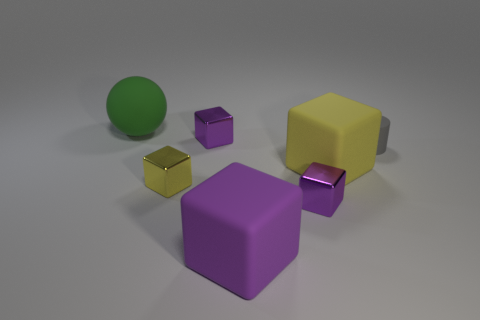Does the yellow object that is in front of the big yellow object have the same material as the tiny gray thing?
Provide a short and direct response. No. Are there any small purple blocks that are behind the green object that is behind the small rubber cylinder that is to the right of the yellow metallic object?
Your answer should be very brief. No. What number of balls are either small matte objects or tiny yellow metallic things?
Offer a terse response. 0. What is the material of the object to the left of the small yellow shiny cube?
Provide a short and direct response. Rubber. Do the tiny thing in front of the small yellow thing and the small cylinder that is behind the tiny yellow cube have the same color?
Provide a succinct answer. No. What number of things are either green matte blocks or tiny purple metallic cubes?
Offer a very short reply. 2. What number of other objects are the same shape as the gray object?
Your answer should be compact. 0. Is the material of the big object behind the tiny gray matte object the same as the yellow object to the right of the purple rubber cube?
Ensure brevity in your answer.  Yes. There is a large rubber thing that is to the left of the yellow matte object and in front of the cylinder; what is its shape?
Keep it short and to the point. Cube. Are there any other things that have the same material as the large green thing?
Your response must be concise. Yes. 